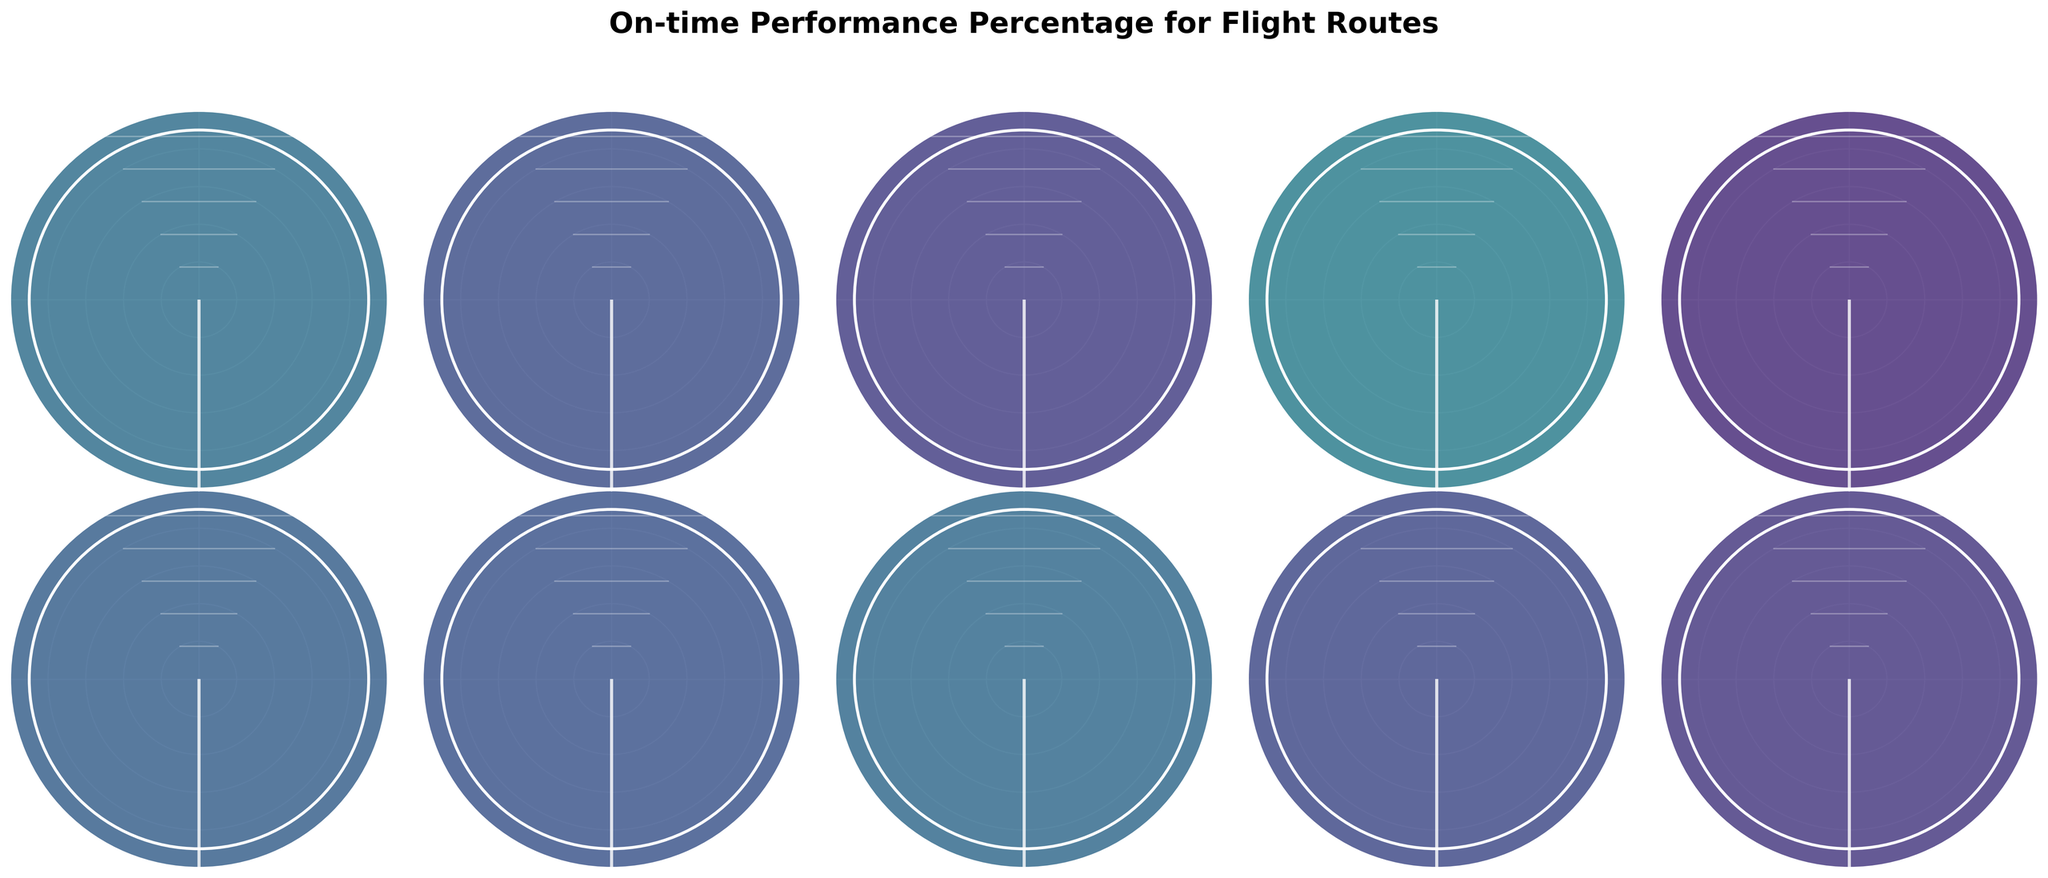Which route has the highest on-time performance percentage? The highest on-time performance percentage can be determined by looking at the route with the highest value displayed on the gauge chart.
Answer: Singapore (SIN) to Hong Kong (HKG) What is the range of on-time performance percentages displayed? The range is determined by finding the difference between the highest and lowest on-time performance percentages. The highest is 94% (SIN to HKG) and the lowest is 79% (ORD to FRA), so the range is 94 - 79.
Answer: 15% How many routes have an on-time performance percentage of 90% or higher? Count the number of routes with an on-time performance percentage that is 90 or above by examining the gauge charts.
Answer: 4 Which route has the lowest on-time performance percentage? The lowest on-time performance percentage is identified by finding the route with the smallest value on the gauge chart.
Answer: Chicago (ORD) to Frankfurt (FRA) What is the average on-time performance percentage across all routes? Sum all the on-time performance percentages and divide by the total number of routes: (82 + 88 + 91 + 79 + 94 + 85 + 87 + 83 + 89 + 92) / 10 = 87
Answer: 87% How does the on-time performance of the New York to London route compare to the Miami to São Paulo route? Compare the percentages of the two routes: New York (JFK) to London (LHR) is 82% and Miami (MIA) to São Paulo (GRU) is 83%.
Answer: Miami (MIA) to São Paulo (GRU) is 1% higher Which European destination has the best on-time performance? Among the European destinations (London (LHR), Frankfurt (FRA), Paris (CDG), Amsterdam (AMS)), identify the highest on-time performance percentage.
Answer: Paris (CDG) to San Francisco (SFO) What is the median on-time performance percentage? Order the percentages and find the middle value. If the number of data points is even, calculate the mean of the two middle values. Ordered: 79, 82, 83, 85, 87, 88, 89, 91, 92, 94. Median = (87 + 88) / 2
Answer: 87.5 How many routes have an on-time performance percentage below 85%? Count the number of routes with an on-time performance percentage below 85% by examining the gauge charts.
Answer: 3 Which route exceeds the average on-time performance percentage? The average on-time performance is 87%. Identify routes with percentages greater than the average.
Answer: LAX to Tokyo (NRT), DXB to SYD, SIN to HKG, SEA to Beijing (PEK), YYZ to Vancouver (YVR) 